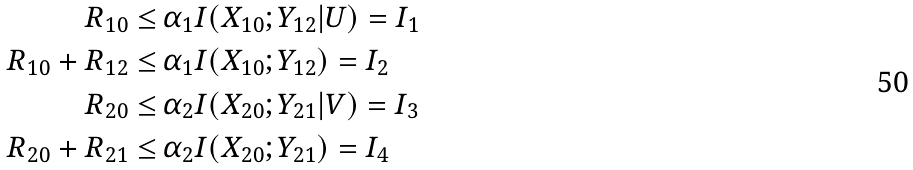Convert formula to latex. <formula><loc_0><loc_0><loc_500><loc_500>R _ { 1 0 } \leq & \, \alpha _ { 1 } I ( X _ { 1 0 } ; Y _ { 1 2 } | U ) = I _ { 1 } \\ R _ { 1 0 } + R _ { 1 2 } \leq & \, \alpha _ { 1 } I ( X _ { 1 0 } ; Y _ { 1 2 } ) = I _ { 2 } \\ R _ { 2 0 } \leq & \, \alpha _ { 2 } I ( X _ { 2 0 } ; Y _ { 2 1 } | V ) = I _ { 3 } \\ R _ { 2 0 } + R _ { 2 1 } \leq & \, \alpha _ { 2 } I ( X _ { 2 0 } ; Y _ { 2 1 } ) = I _ { 4 }</formula> 